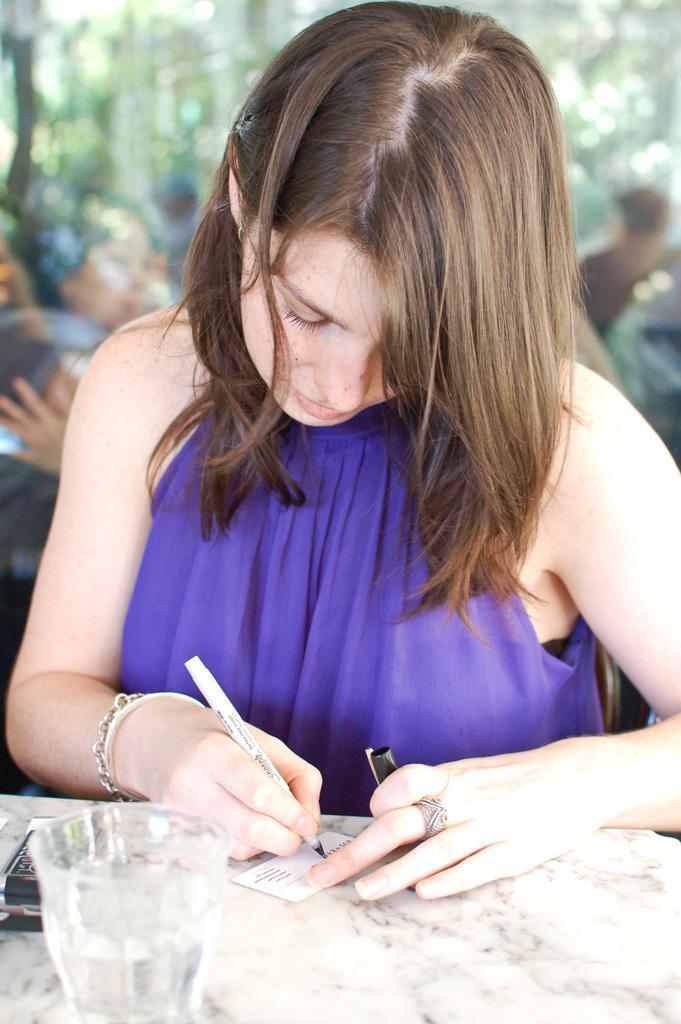Describe this image in one or two sentences. In this image we can see a lady holding a pen and writing something on the card. There is a table on which there is glass. The background of the image is not clear. 